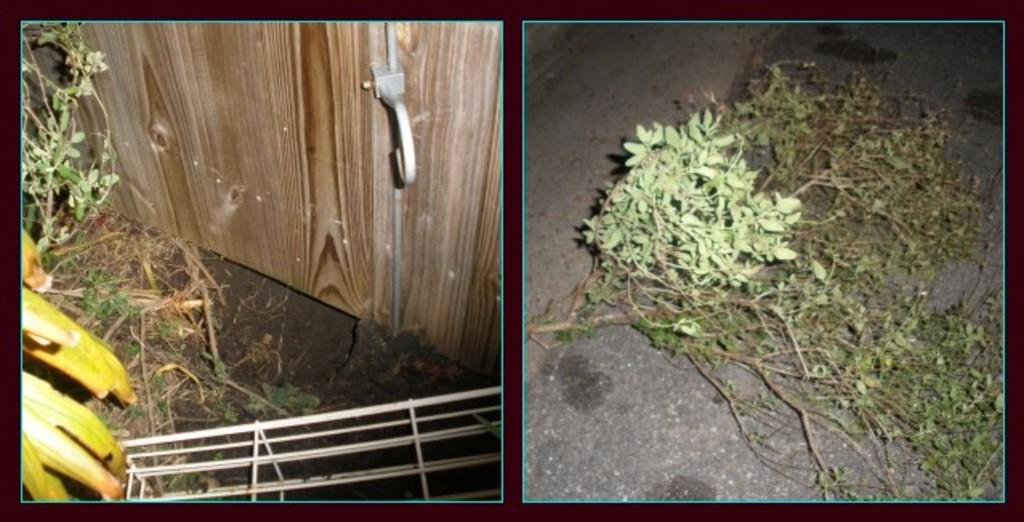What material is the board in the image made of? The wooden board in the image is made of wood. What else can be seen in the image besides the wooden board? There are plants in the image. What type of fear can be seen on the wooden board in the image? There is no fear present in the image, as it is a wooden board and plants. What type of sofa is visible in the image? There is no sofa present in the image, as it only contains a wooden board and plants. 